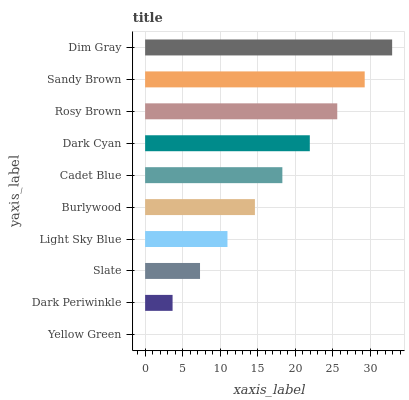Is Yellow Green the minimum?
Answer yes or no. Yes. Is Dim Gray the maximum?
Answer yes or no. Yes. Is Dark Periwinkle the minimum?
Answer yes or no. No. Is Dark Periwinkle the maximum?
Answer yes or no. No. Is Dark Periwinkle greater than Yellow Green?
Answer yes or no. Yes. Is Yellow Green less than Dark Periwinkle?
Answer yes or no. Yes. Is Yellow Green greater than Dark Periwinkle?
Answer yes or no. No. Is Dark Periwinkle less than Yellow Green?
Answer yes or no. No. Is Cadet Blue the high median?
Answer yes or no. Yes. Is Burlywood the low median?
Answer yes or no. Yes. Is Light Sky Blue the high median?
Answer yes or no. No. Is Cadet Blue the low median?
Answer yes or no. No. 